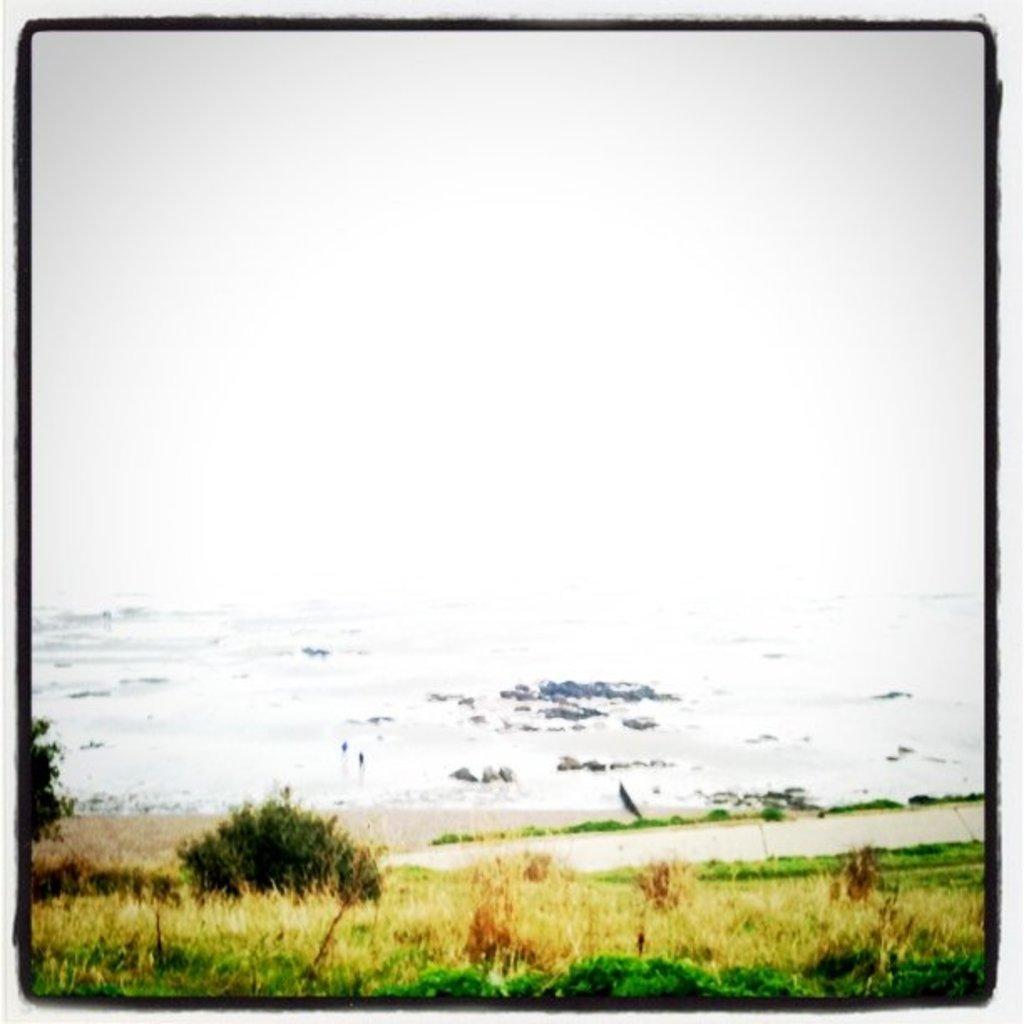Please provide a concise description of this image. In this image we can see a painting which includes grass, plants, water, stones. 